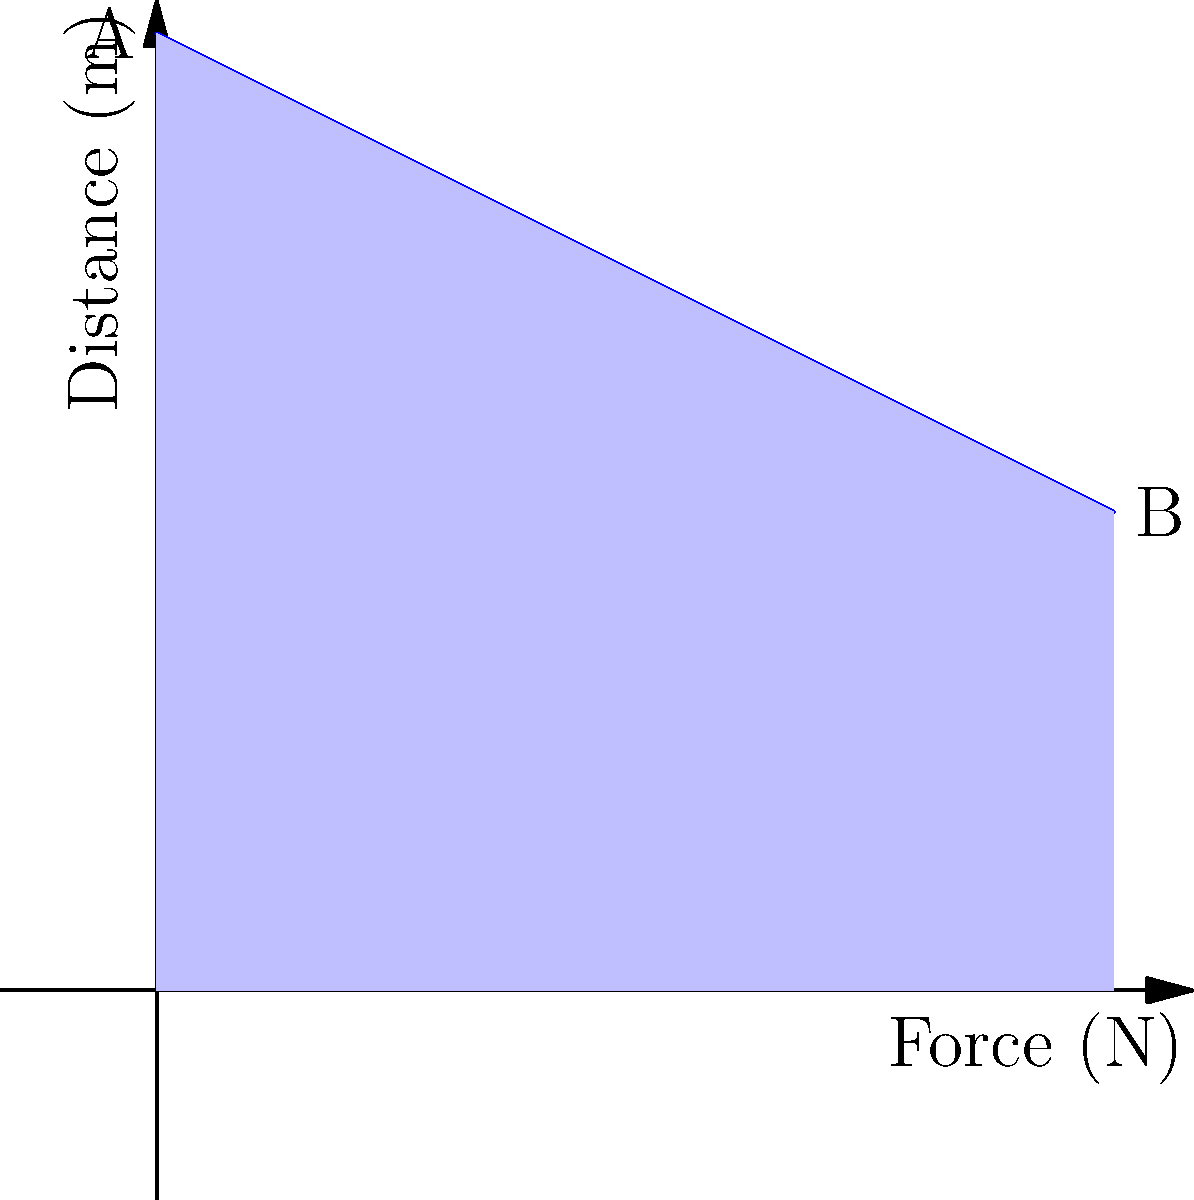In an art gallery, you need to move a valuable sculpture from one pedestal to another. The sculpture weighs 200 N, and you need to lift it 1 meter high and move it horizontally for 2 meters. The force required to move the sculpture decreases linearly as you lift it due to improved leverage. If the initial force is 200 N and the final force is 100 N, calculate the total work done in joules. To solve this problem, we'll break it down into steps:

1. Understand the given information:
   - Initial force: $F_i = 200$ N
   - Final force: $F_f = 100$ N
   - Vertical distance: $h = 1$ m
   - Horizontal distance: $d = 2$ m

2. Calculate the work done in lifting the sculpture vertically:
   - The force decreases linearly from 200 N to 100 N over 1 meter
   - Average force: $F_{avg} = (F_i + F_f) / 2 = (200 + 100) / 2 = 150$ N
   - Work done in lifting: $W_{lift} = F_{avg} \times h = 150 \text{ N} \times 1 \text{ m} = 150 \text{ J}$

3. Calculate the work done in moving the sculpture horizontally:
   - The force remains constant at 100 N for 2 meters
   - Work done in moving: $W_{move} = F_f \times d = 100 \text{ N} \times 2 \text{ m} = 200 \text{ J}$

4. Sum up the total work done:
   Total work = $W_{lift} + W_{move} = 150 \text{ J} + 200 \text{ J} = 350 \text{ J}$

The graph shows the force-distance relationship for the lifting phase. The area under the curve represents the work done during lifting, which is a trapezoid with an area of 150 J.
Answer: 350 J 